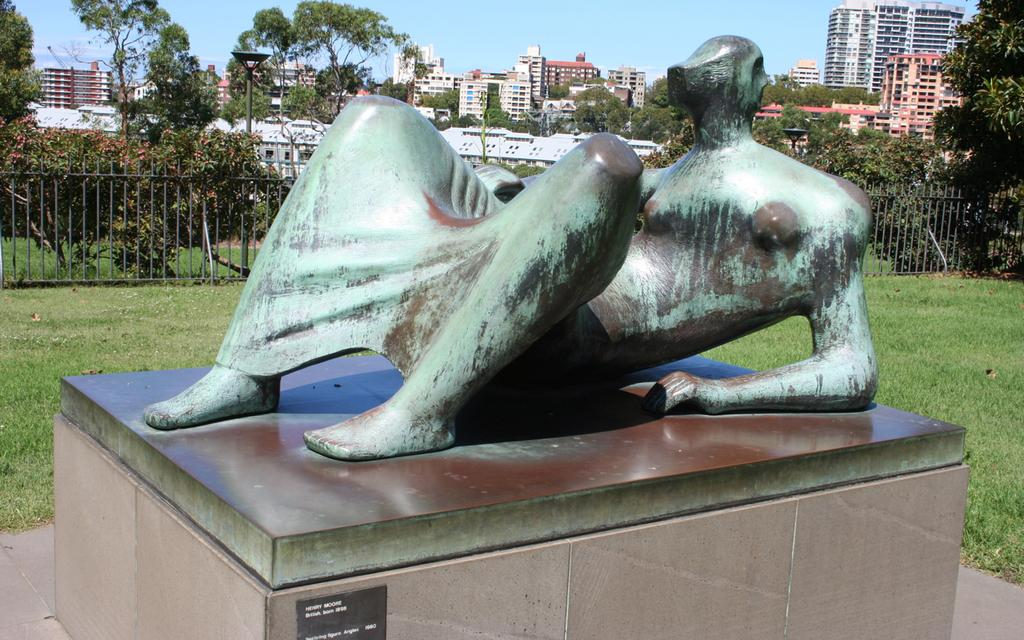What is the main subject in the image? There is a statue in the image. Where is the statue located in relation to other objects? The statue is in front of a fence. What type of vegetation can be seen in the image? There are trees in the top left of the image. What type of structures are visible in the image? There are buildings visible in the image. What is visible at the top of the image? The sky is visible at the top of the image. What type of cup is being used to develop the statue in the image? There is no cup or development process depicted in the image; it features a statue in front of a fence with trees, buildings, and sky visible. 